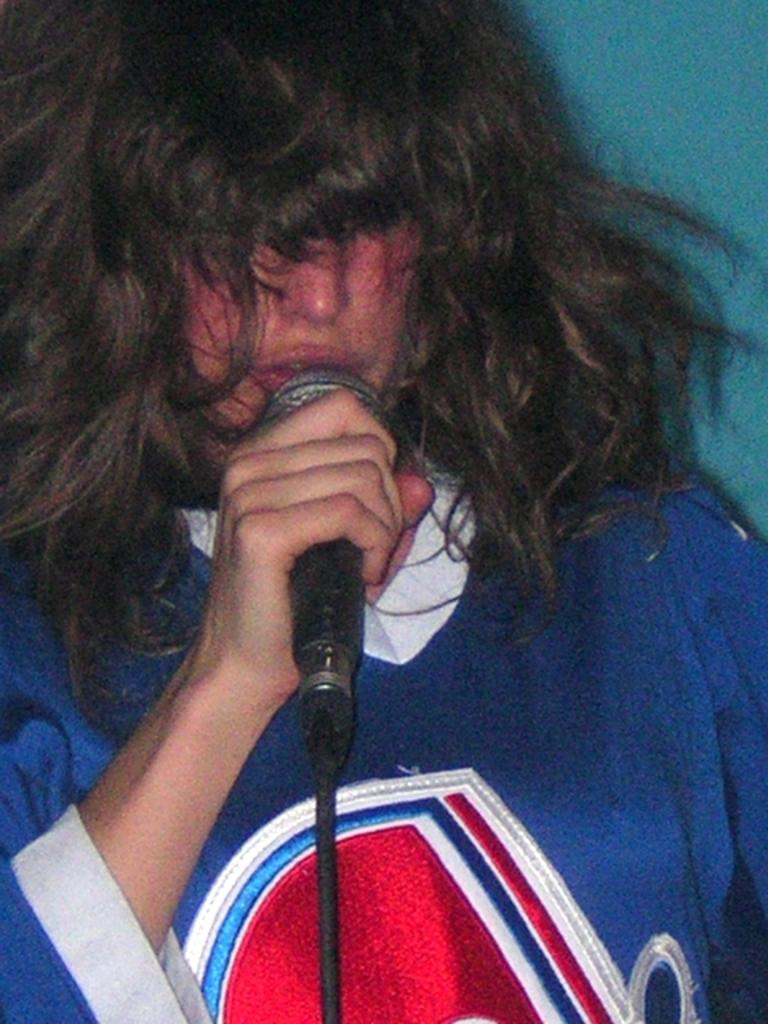What is the main subject of the image? There is a person in the image. What is the person holding in the image? The person is holding a microphone. Where is the person located in the image? The person is in the center of the image. What type of card is the person using to play volleyball in the image? There is no card or volleyball present in the image; the person is holding a microphone. 